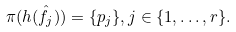<formula> <loc_0><loc_0><loc_500><loc_500>\pi ( h ( \hat { f } _ { j } ) ) = \{ p _ { j } \} , j \in \{ 1 , \dots , r \} .</formula> 